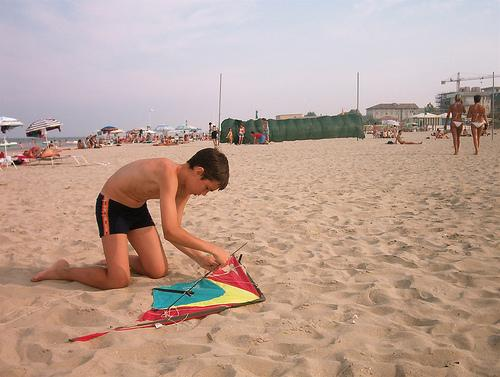Where does he hope his toy will go? Please explain your reasoning. sky. The boy is playing with a kite on the beach. 